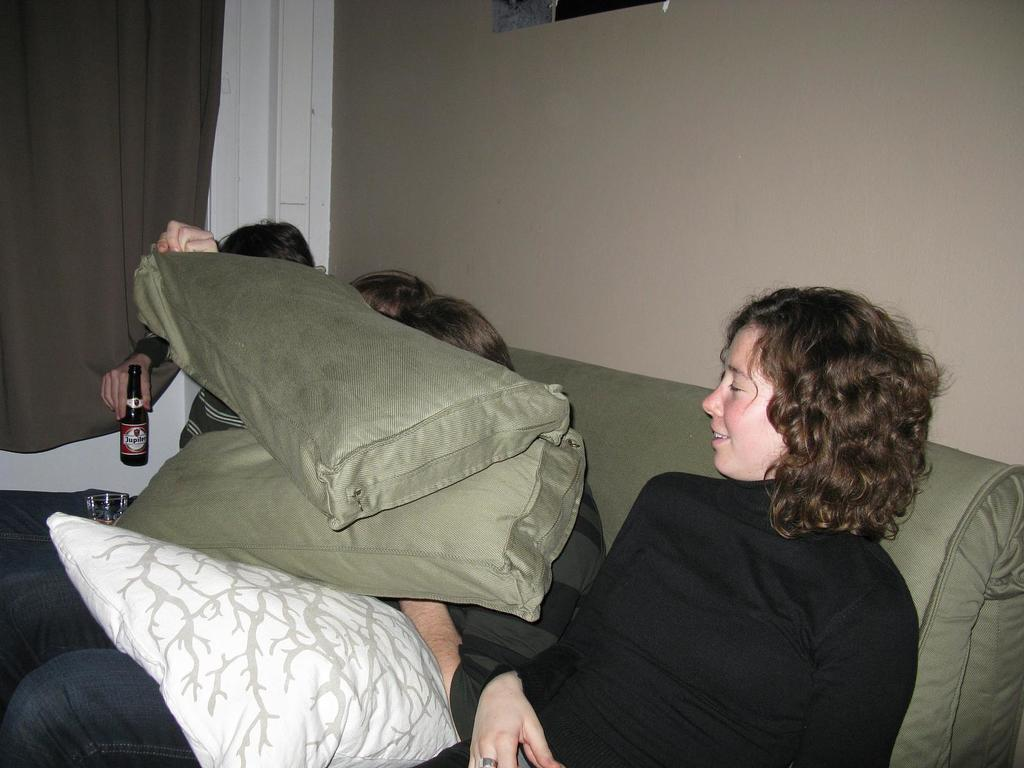What type of structure can be seen in the image? There is a wall in the image. What is hanging near the wall in the image? There is a curtain hanging near the wall in the image. What are the people in the image doing? The people in the image are sleeping on a bed. What items can be seen on the bed in the image? There are pillows visible on the bed in the image. What type of pollution can be seen in the image? There is no pollution visible in the image. What hour of the day is depicted in the image? The provided facts do not give any information about the time of day, so it cannot be determined from the image. 